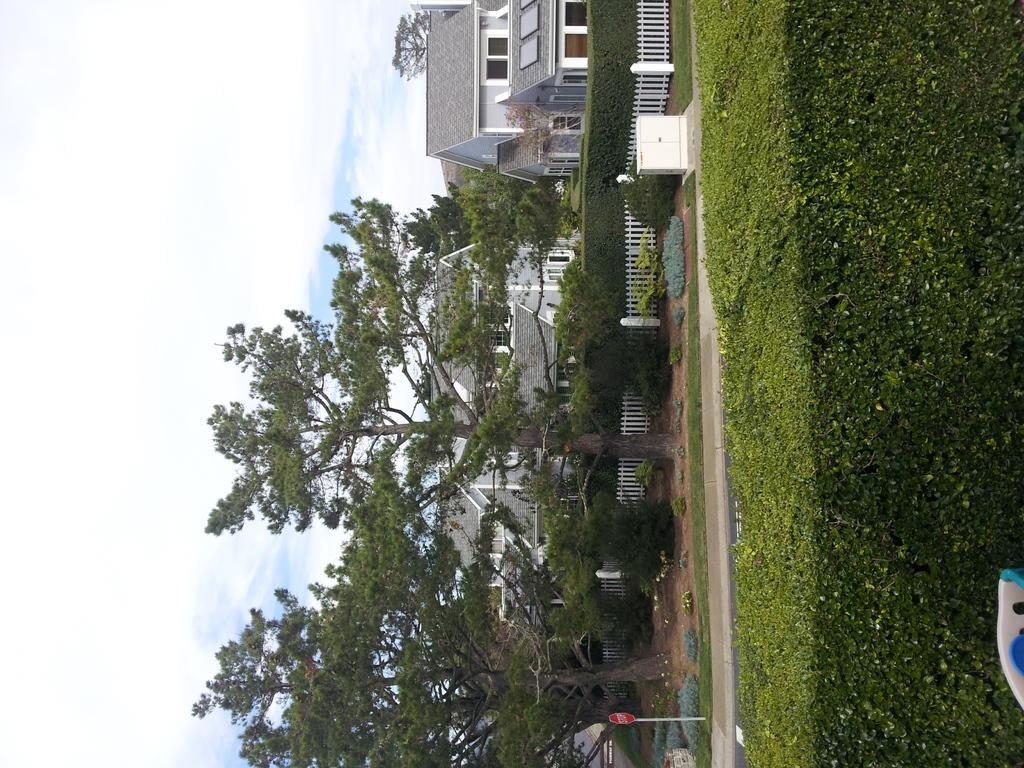What type of outdoor space is visible in the image? There is a lawn in the image. What object is present to indicate a stop or pause? There is a stop board in the image. What type of barrier can be seen in the image? There is a fence in the image. What type of vegetation is present in the image? There are trees in the image. What type of structures are visible in the image? There are houses in the image. What can be seen in the background of the image? The sky with clouds is visible in the background of the image. Can you see any toes in the image? There are no toes visible in the image. What type of emotion is being expressed by the kite in the image? There is no kite present in the image, so it is not possible to determine any emotions being expressed by it. 